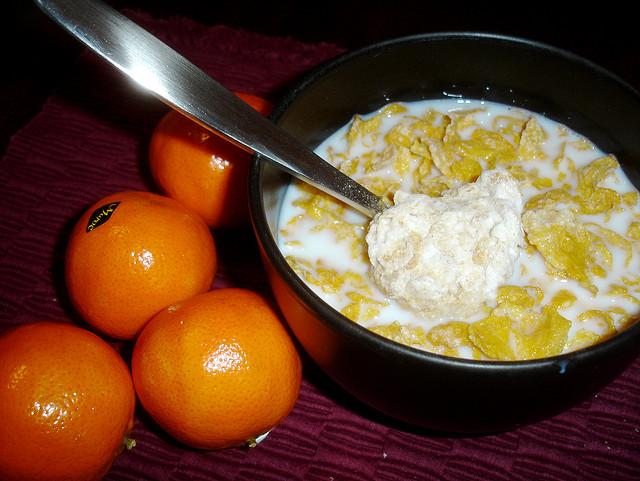Is there any cereal in the pot?
Short answer required. Yes. Do any of the foods have stickers on them?
Be succinct. Yes. How many oranges are there?
Be succinct. 4. 